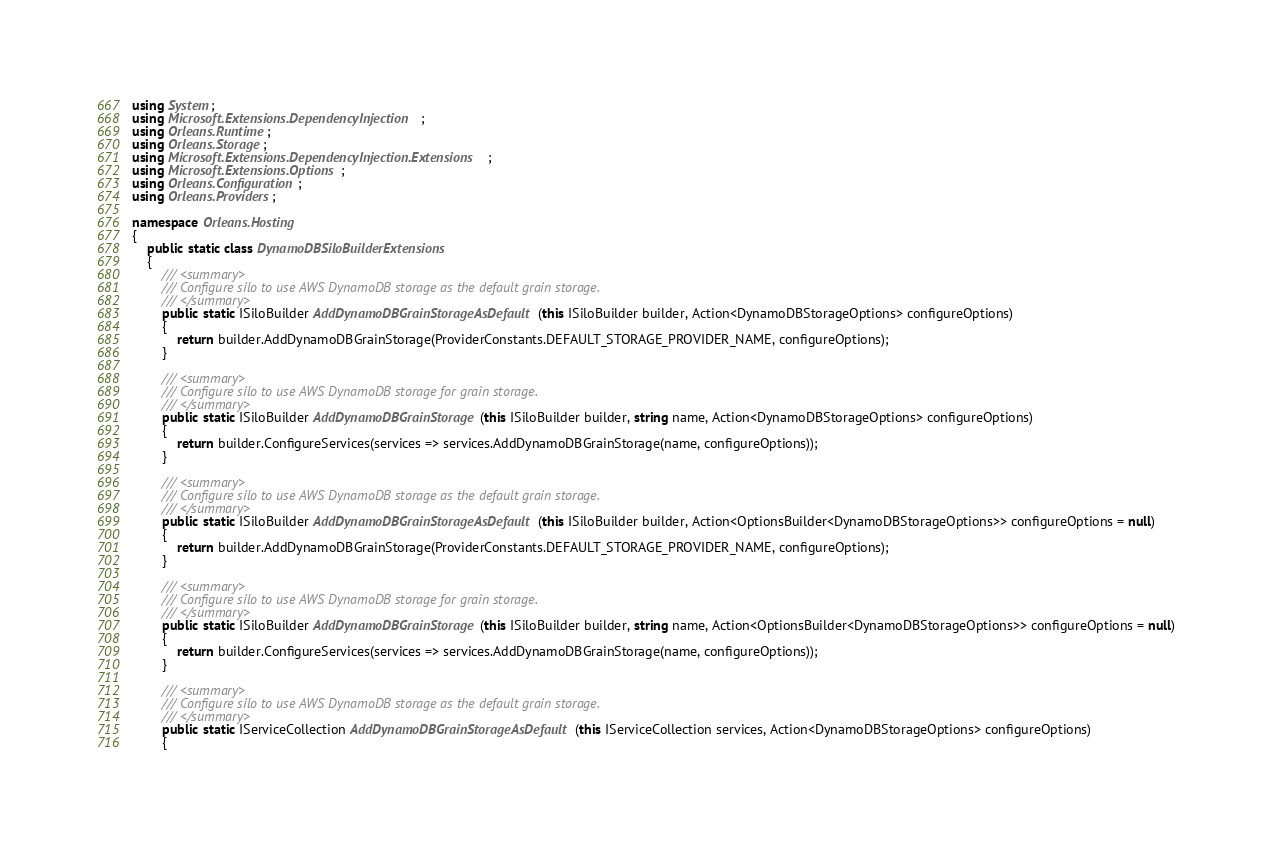<code> <loc_0><loc_0><loc_500><loc_500><_C#_>using System;
using Microsoft.Extensions.DependencyInjection;
using Orleans.Runtime;
using Orleans.Storage;
using Microsoft.Extensions.DependencyInjection.Extensions;
using Microsoft.Extensions.Options;
using Orleans.Configuration;
using Orleans.Providers;

namespace Orleans.Hosting
{
    public static class DynamoDBSiloBuilderExtensions
    {
        /// <summary>
        /// Configure silo to use AWS DynamoDB storage as the default grain storage.
        /// </summary>
        public static ISiloBuilder AddDynamoDBGrainStorageAsDefault(this ISiloBuilder builder, Action<DynamoDBStorageOptions> configureOptions)
        {
            return builder.AddDynamoDBGrainStorage(ProviderConstants.DEFAULT_STORAGE_PROVIDER_NAME, configureOptions);
        }

        /// <summary>
        /// Configure silo to use AWS DynamoDB storage for grain storage.
        /// </summary>
        public static ISiloBuilder AddDynamoDBGrainStorage(this ISiloBuilder builder, string name, Action<DynamoDBStorageOptions> configureOptions)
        {
            return builder.ConfigureServices(services => services.AddDynamoDBGrainStorage(name, configureOptions));
        }

        /// <summary>
        /// Configure silo to use AWS DynamoDB storage as the default grain storage.
        /// </summary>
        public static ISiloBuilder AddDynamoDBGrainStorageAsDefault(this ISiloBuilder builder, Action<OptionsBuilder<DynamoDBStorageOptions>> configureOptions = null)
        {
            return builder.AddDynamoDBGrainStorage(ProviderConstants.DEFAULT_STORAGE_PROVIDER_NAME, configureOptions);
        }

        /// <summary>
        /// Configure silo to use AWS DynamoDB storage for grain storage.
        /// </summary>
        public static ISiloBuilder AddDynamoDBGrainStorage(this ISiloBuilder builder, string name, Action<OptionsBuilder<DynamoDBStorageOptions>> configureOptions = null)
        {
            return builder.ConfigureServices(services => services.AddDynamoDBGrainStorage(name, configureOptions));
        }

        /// <summary>
        /// Configure silo to use AWS DynamoDB storage as the default grain storage.
        /// </summary>
        public static IServiceCollection AddDynamoDBGrainStorageAsDefault(this IServiceCollection services, Action<DynamoDBStorageOptions> configureOptions)
        {</code> 